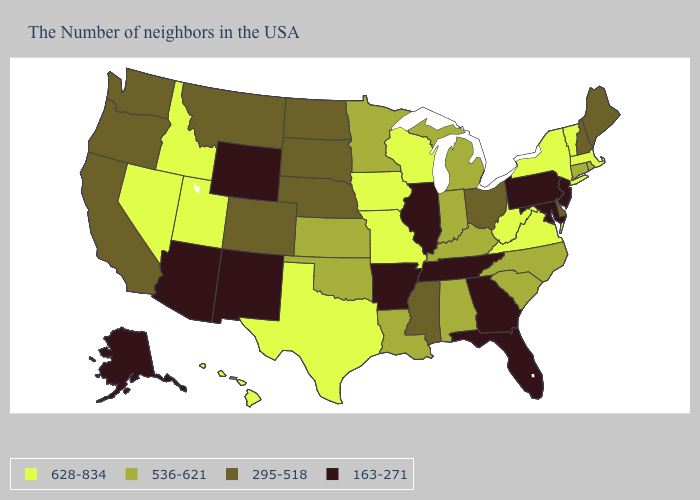Among the states that border Montana , which have the highest value?
Give a very brief answer. Idaho. Name the states that have a value in the range 628-834?
Be succinct. Massachusetts, Vermont, New York, Virginia, West Virginia, Wisconsin, Missouri, Iowa, Texas, Utah, Idaho, Nevada, Hawaii. Among the states that border Ohio , which have the lowest value?
Give a very brief answer. Pennsylvania. What is the highest value in the USA?
Give a very brief answer. 628-834. What is the value of Florida?
Give a very brief answer. 163-271. Among the states that border Montana , which have the highest value?
Concise answer only. Idaho. Which states hav the highest value in the West?
Short answer required. Utah, Idaho, Nevada, Hawaii. Does the first symbol in the legend represent the smallest category?
Be succinct. No. What is the highest value in the USA?
Give a very brief answer. 628-834. Name the states that have a value in the range 295-518?
Be succinct. Maine, New Hampshire, Delaware, Ohio, Mississippi, Nebraska, South Dakota, North Dakota, Colorado, Montana, California, Washington, Oregon. What is the value of Georgia?
Answer briefly. 163-271. Does New Jersey have the highest value in the Northeast?
Concise answer only. No. Does Ohio have the highest value in the USA?
Give a very brief answer. No. Does South Carolina have the same value as Indiana?
Concise answer only. Yes. Does Wyoming have the lowest value in the West?
Short answer required. Yes. 